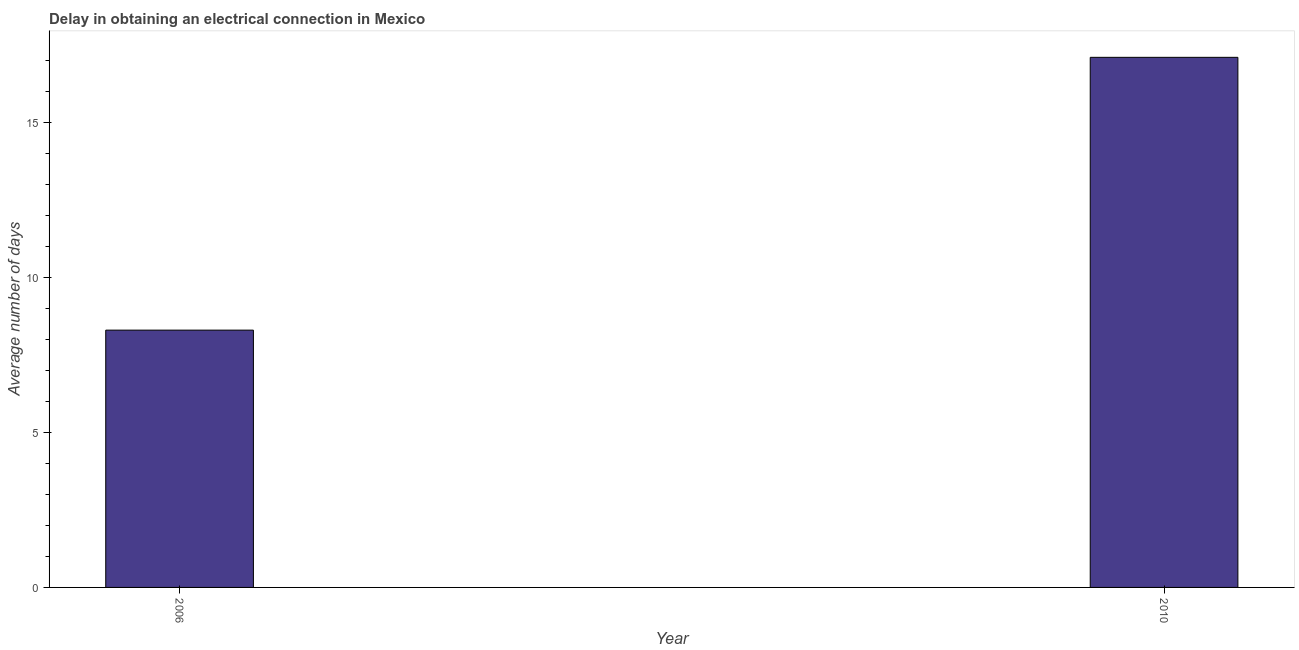What is the title of the graph?
Provide a short and direct response. Delay in obtaining an electrical connection in Mexico. What is the label or title of the Y-axis?
Provide a succinct answer. Average number of days. What is the dalay in electrical connection in 2006?
Provide a short and direct response. 8.3. Across all years, what is the minimum dalay in electrical connection?
Ensure brevity in your answer.  8.3. In which year was the dalay in electrical connection maximum?
Provide a short and direct response. 2010. What is the sum of the dalay in electrical connection?
Offer a terse response. 25.4. What is the median dalay in electrical connection?
Your answer should be compact. 12.7. In how many years, is the dalay in electrical connection greater than 11 days?
Offer a very short reply. 1. Do a majority of the years between 2006 and 2010 (inclusive) have dalay in electrical connection greater than 7 days?
Your answer should be very brief. Yes. What is the ratio of the dalay in electrical connection in 2006 to that in 2010?
Offer a very short reply. 0.48. How many bars are there?
Provide a succinct answer. 2. Are all the bars in the graph horizontal?
Offer a very short reply. No. How many years are there in the graph?
Provide a succinct answer. 2. What is the difference between two consecutive major ticks on the Y-axis?
Your response must be concise. 5. What is the Average number of days of 2010?
Provide a succinct answer. 17.1. What is the difference between the Average number of days in 2006 and 2010?
Your response must be concise. -8.8. What is the ratio of the Average number of days in 2006 to that in 2010?
Your response must be concise. 0.48. 